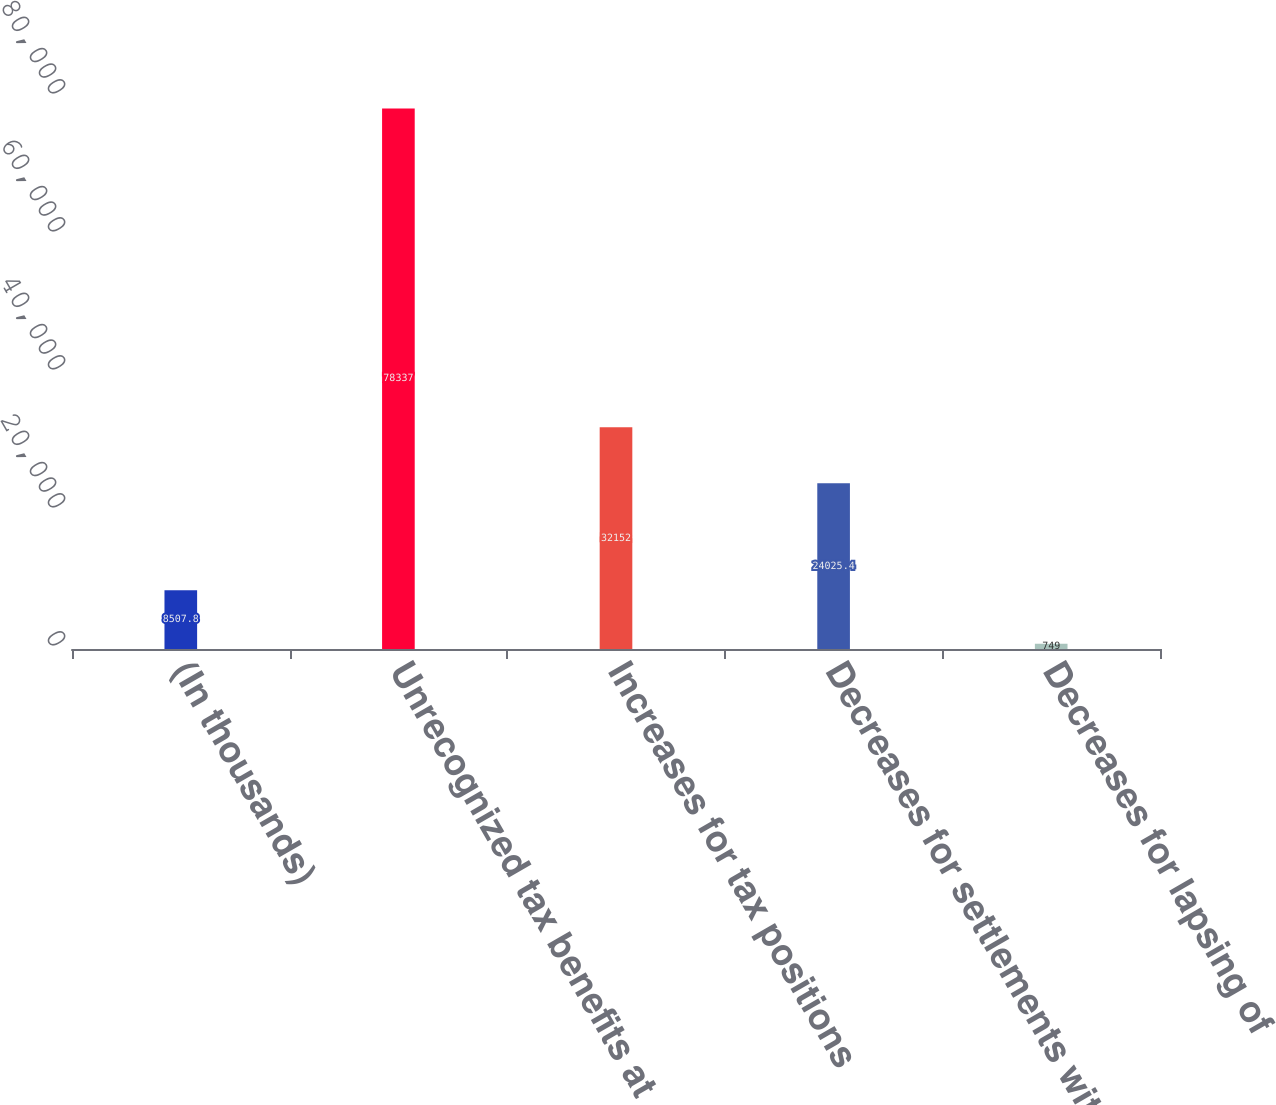Convert chart to OTSL. <chart><loc_0><loc_0><loc_500><loc_500><bar_chart><fcel>(In thousands)<fcel>Unrecognized tax benefits at<fcel>Increases for tax positions<fcel>Decreases for settlements with<fcel>Decreases for lapsing of<nl><fcel>8507.8<fcel>78337<fcel>32152<fcel>24025.4<fcel>749<nl></chart> 